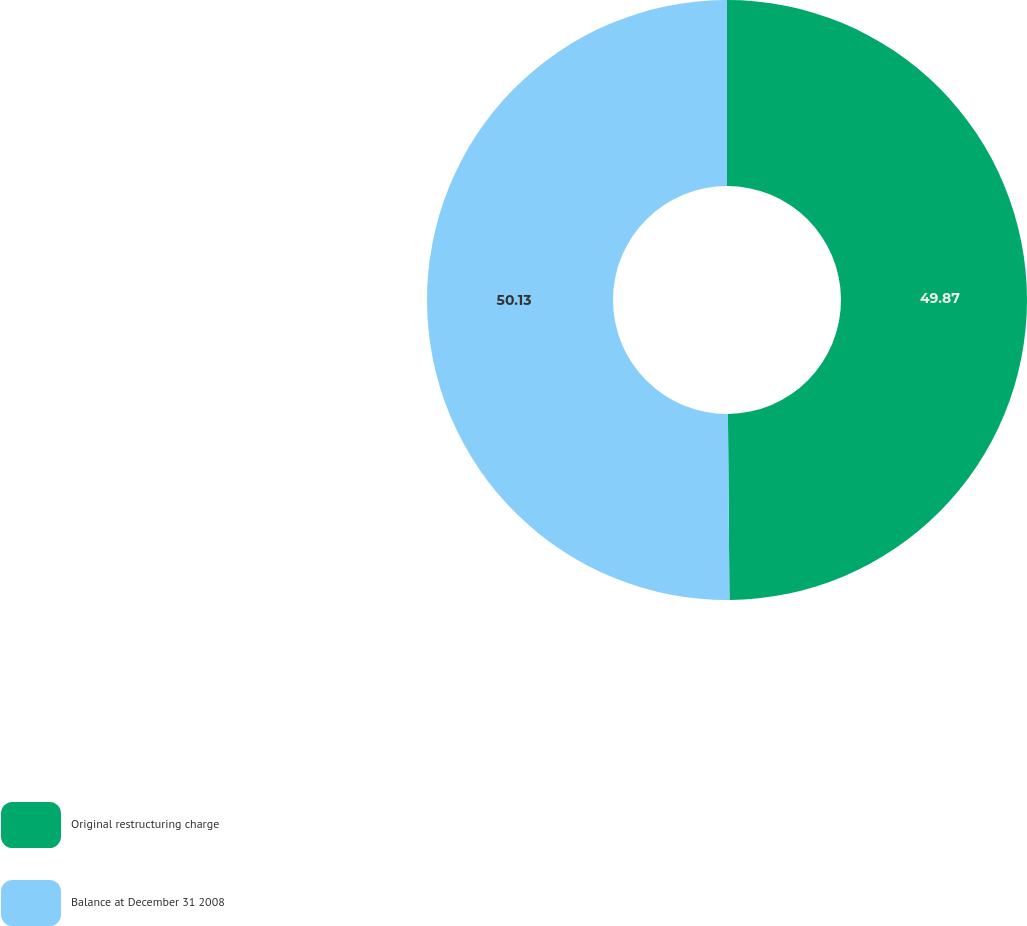Convert chart. <chart><loc_0><loc_0><loc_500><loc_500><pie_chart><fcel>Original restructuring charge<fcel>Balance at December 31 2008<nl><fcel>49.87%<fcel>50.13%<nl></chart> 